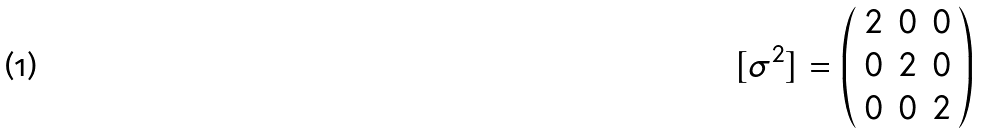Convert formula to latex. <formula><loc_0><loc_0><loc_500><loc_500>[ \sigma ^ { 2 } ] = \left ( \begin{array} { c c c } 2 & 0 & 0 \\ 0 & 2 & 0 \\ 0 & 0 & 2 \end{array} \right )</formula> 